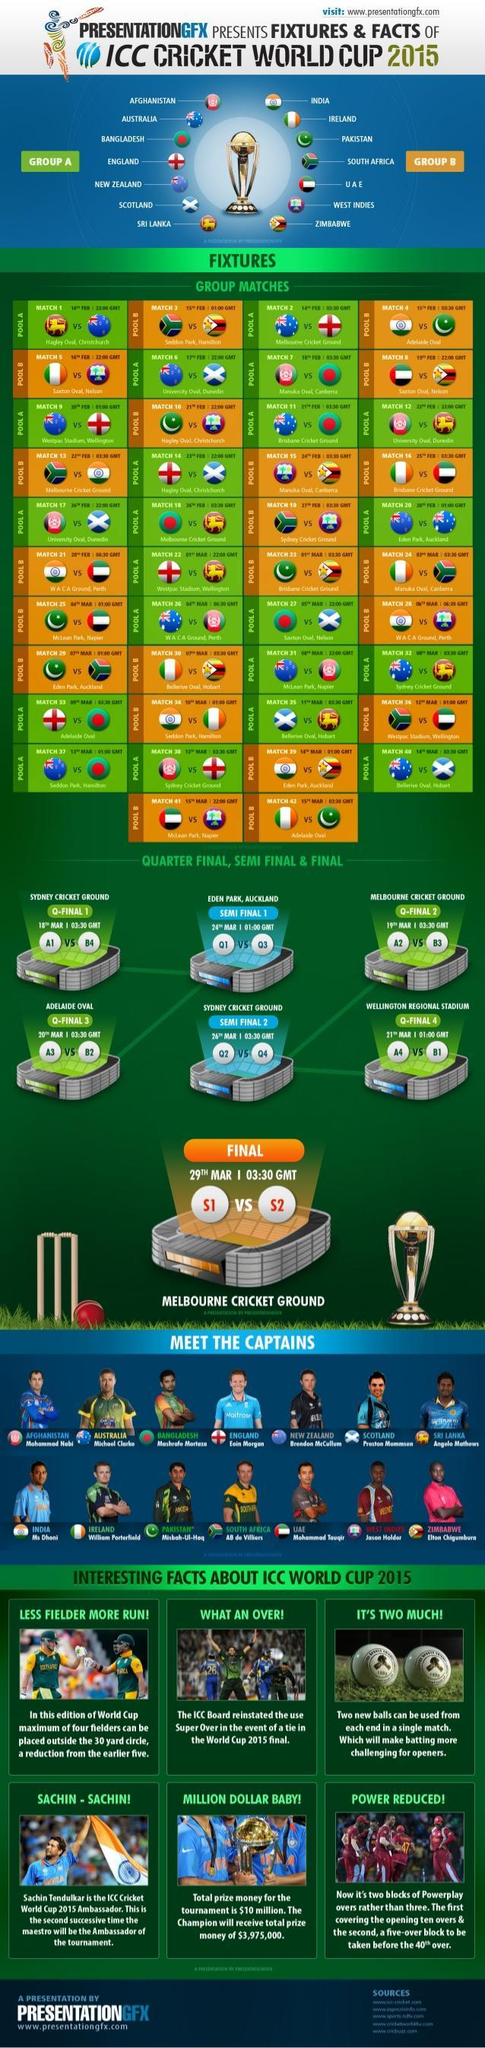Which are the countries from Africa in Group B
Answer the question with a short phrase. South Africa, West Indies, Zimbabwe WHich date is the Q-Final 1 match 18th Mar Who is the Indian Captain MS Dhoni Brendon McCullum is the captain for which team New Zealand How many fielders have been reduced in the 2015 world cup from outside the 30 yard circle when compared to the count in the previous match 1 Which date is the match between India and Pakistan for Fixtures 15th Feb Which are the Asian countries in Group A Afghanistan, Bangladesh, Sri Lanka Which date is the fixtures match between Srilanka and New Zealand 14th Feb 